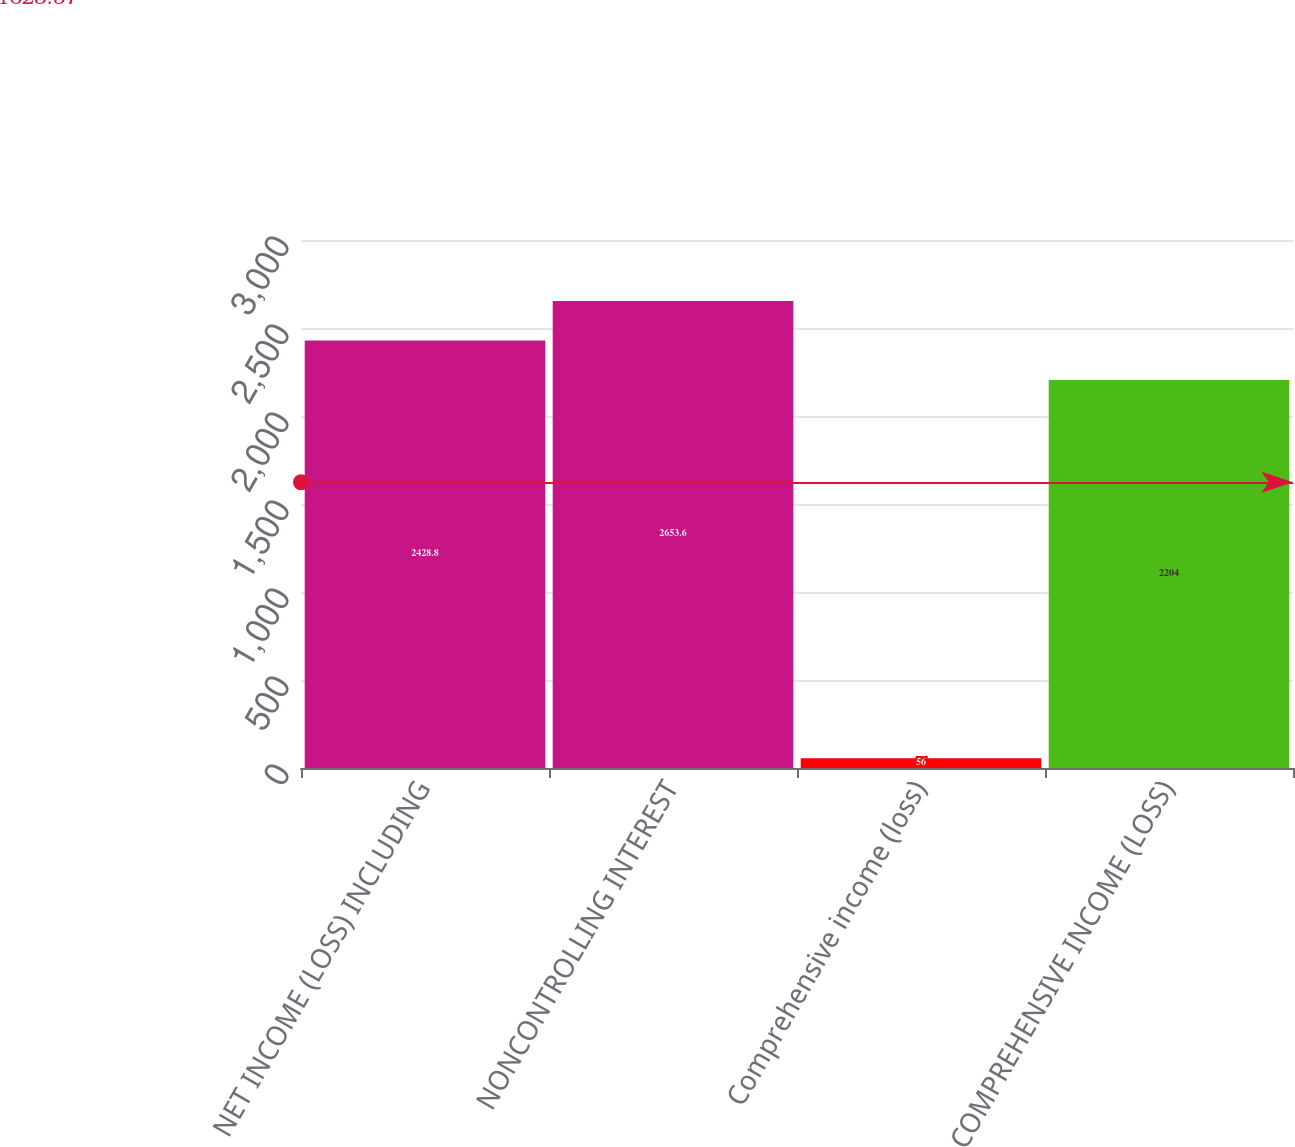<chart> <loc_0><loc_0><loc_500><loc_500><bar_chart><fcel>NET INCOME (LOSS) INCLUDING<fcel>NONCONTROLLING INTEREST<fcel>Comprehensive income (loss)<fcel>COMPREHENSIVE INCOME (LOSS)<nl><fcel>2428.8<fcel>2653.6<fcel>56<fcel>2204<nl></chart> 